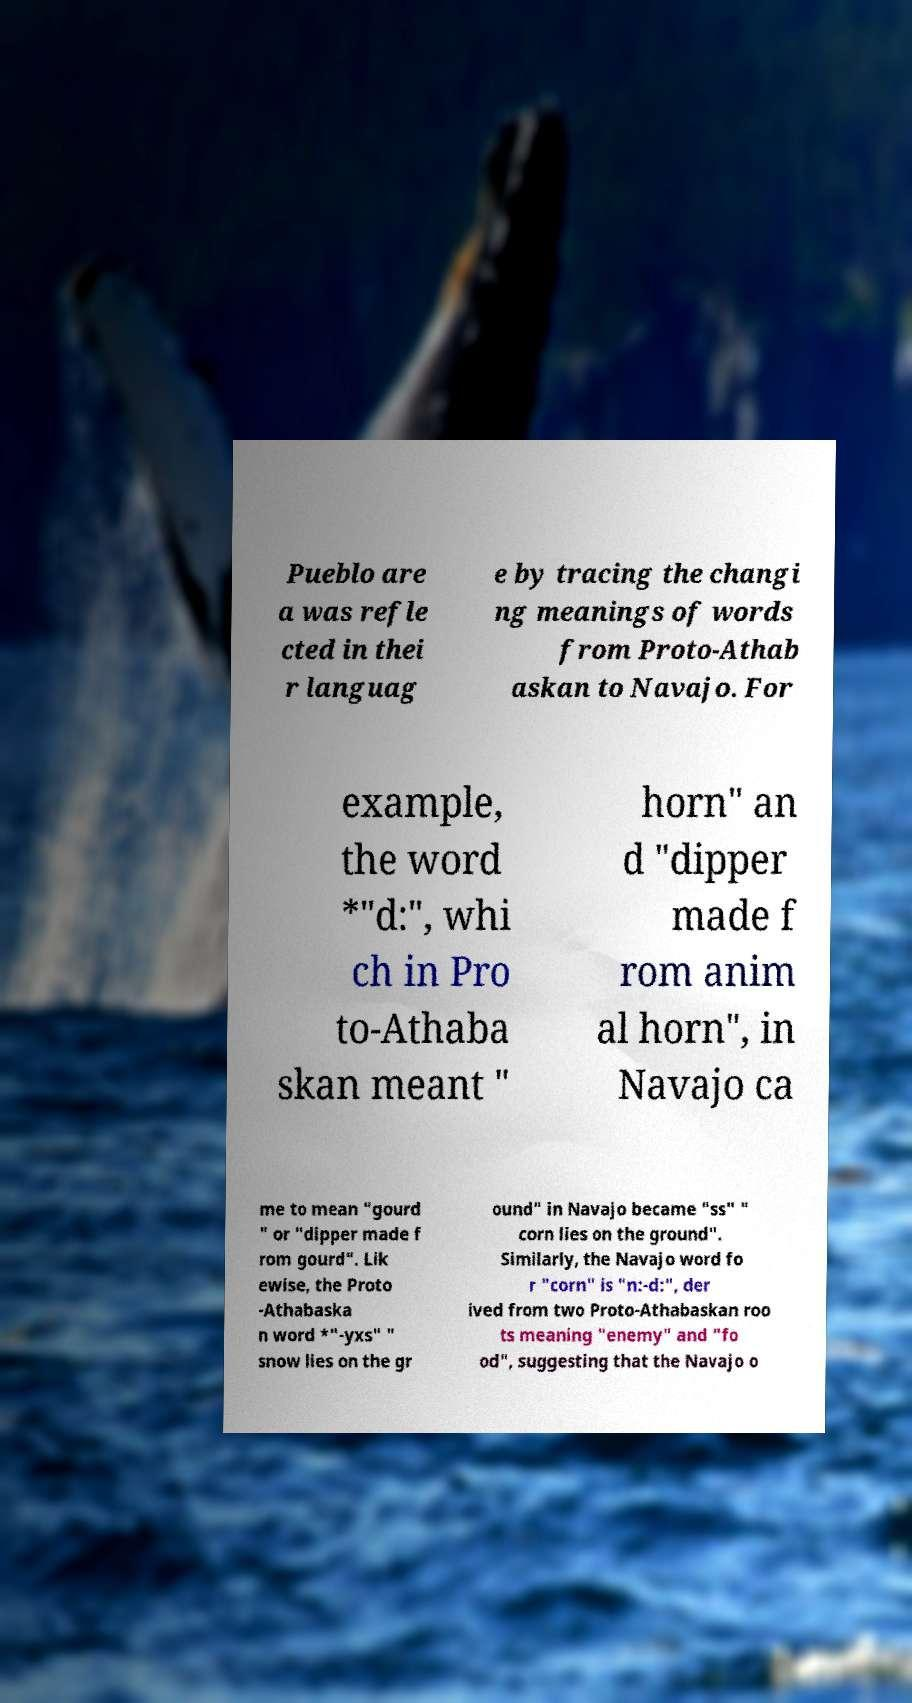Please identify and transcribe the text found in this image. Pueblo are a was refle cted in thei r languag e by tracing the changi ng meanings of words from Proto-Athab askan to Navajo. For example, the word *"d:", whi ch in Pro to-Athaba skan meant " horn" an d "dipper made f rom anim al horn", in Navajo ca me to mean "gourd " or "dipper made f rom gourd". Lik ewise, the Proto -Athabaska n word *"-yxs" " snow lies on the gr ound" in Navajo became "ss" " corn lies on the ground". Similarly, the Navajo word fo r "corn" is "n:-d:", der ived from two Proto-Athabaskan roo ts meaning "enemy" and "fo od", suggesting that the Navajo o 